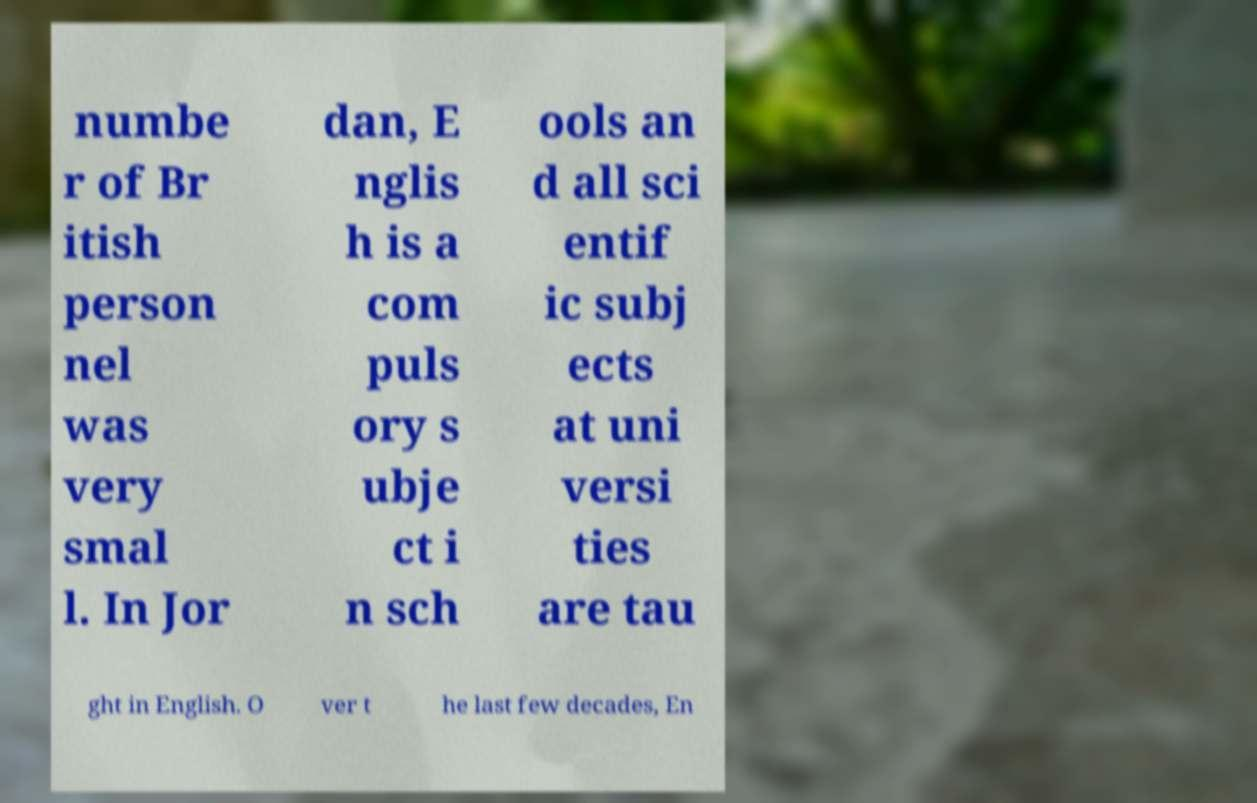For documentation purposes, I need the text within this image transcribed. Could you provide that? numbe r of Br itish person nel was very smal l. In Jor dan, E nglis h is a com puls ory s ubje ct i n sch ools an d all sci entif ic subj ects at uni versi ties are tau ght in English. O ver t he last few decades, En 